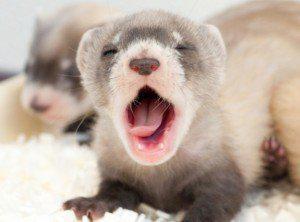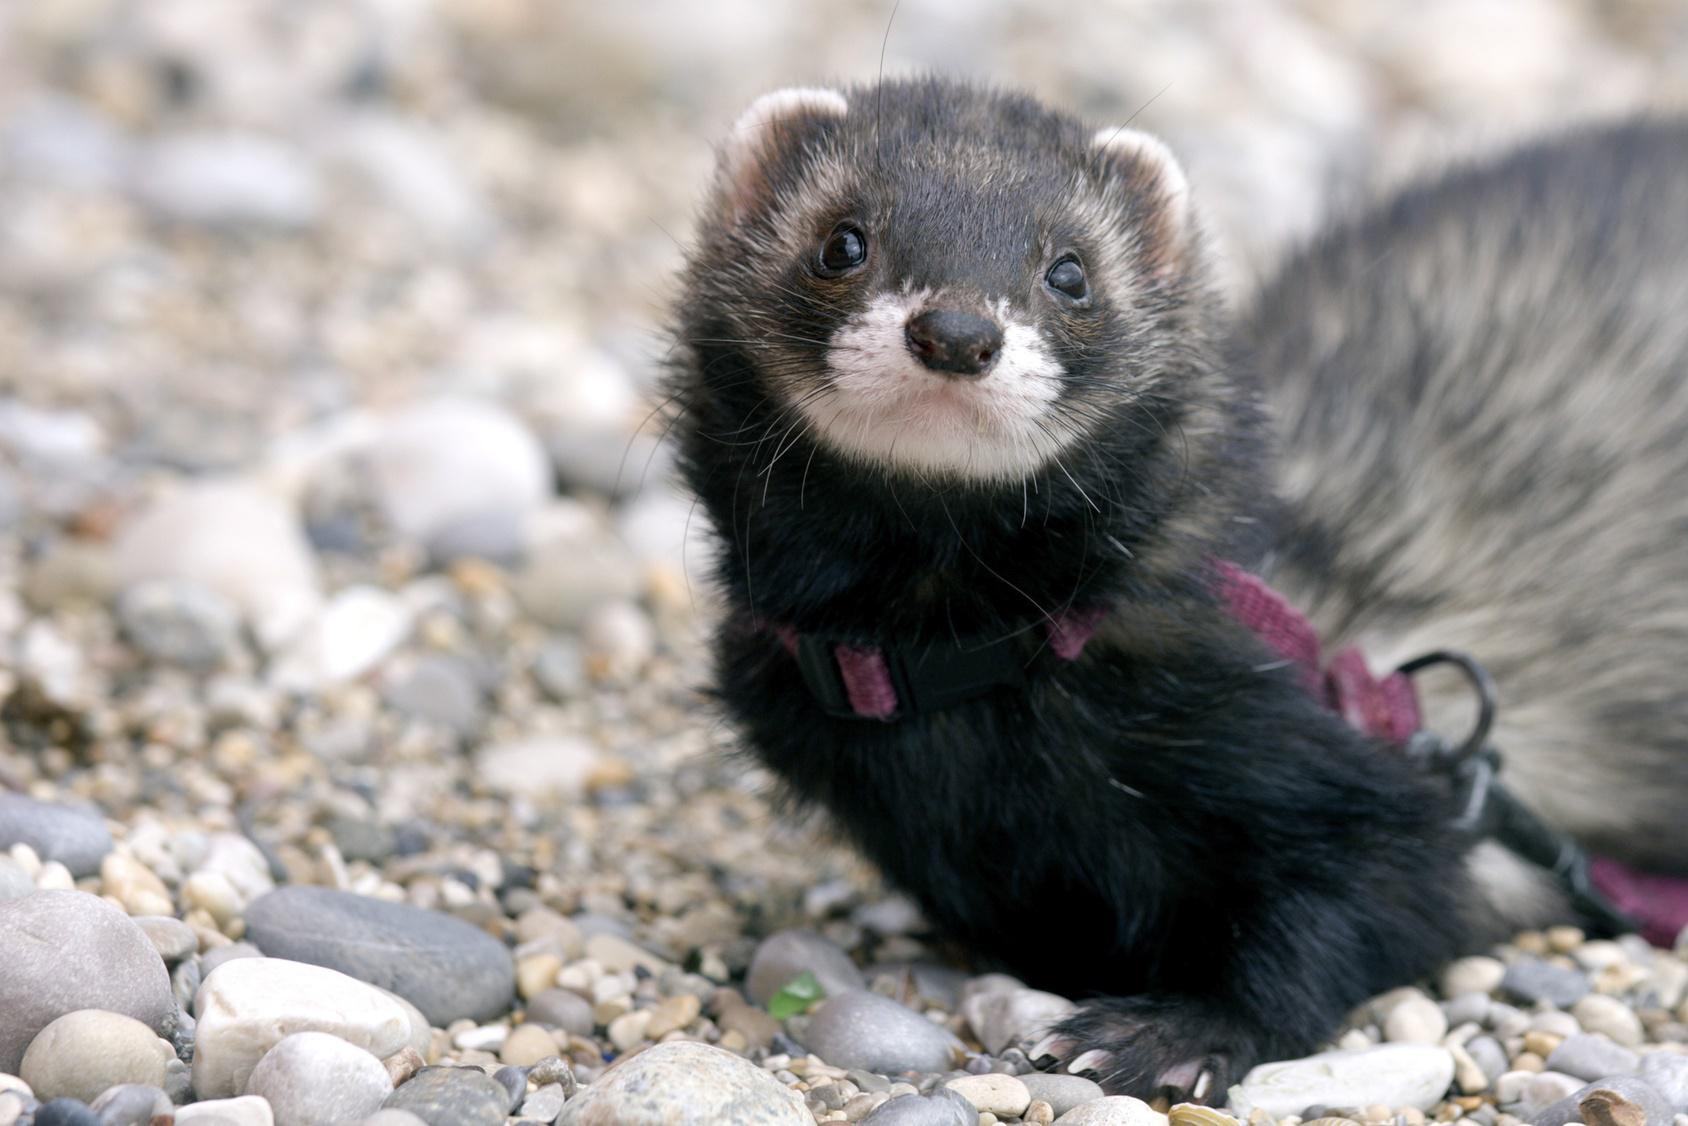The first image is the image on the left, the second image is the image on the right. Assess this claim about the two images: "The right image features a human hand holding a ferret.". Correct or not? Answer yes or no. No. 